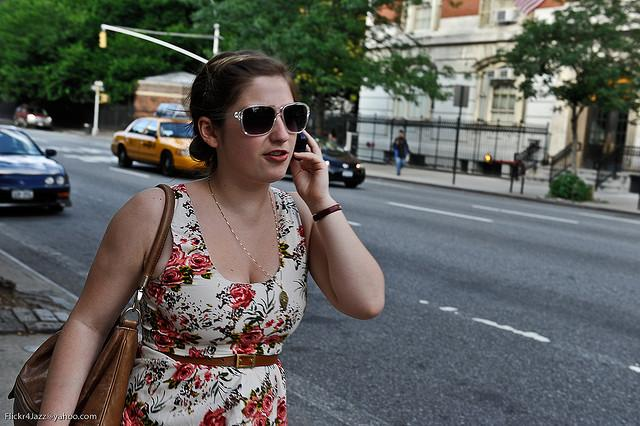What is the woman wearing sunglasses doing?

Choices:
A) crossing street
B) talking
C) listening
D) recording talking 